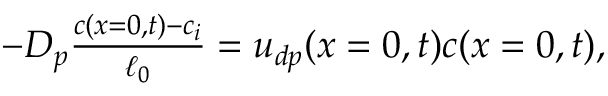<formula> <loc_0><loc_0><loc_500><loc_500>\begin{array} { r } { - D _ { p } \frac { c ( x = 0 , t ) - c _ { i } } { \ell _ { 0 } } = u _ { d p } ( x = 0 , t ) c ( x = 0 , t ) , } \end{array}</formula> 